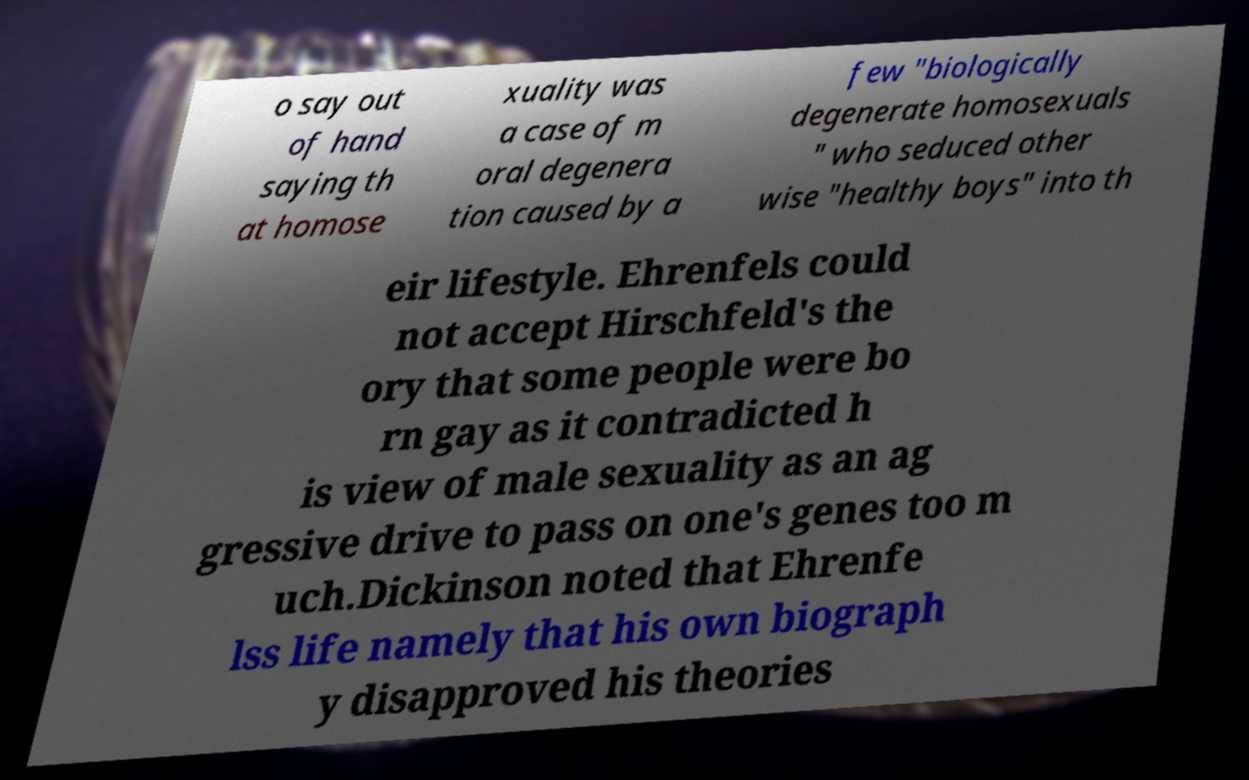What messages or text are displayed in this image? I need them in a readable, typed format. o say out of hand saying th at homose xuality was a case of m oral degenera tion caused by a few "biologically degenerate homosexuals " who seduced other wise "healthy boys" into th eir lifestyle. Ehrenfels could not accept Hirschfeld's the ory that some people were bo rn gay as it contradicted h is view of male sexuality as an ag gressive drive to pass on one's genes too m uch.Dickinson noted that Ehrenfe lss life namely that his own biograph y disapproved his theories 